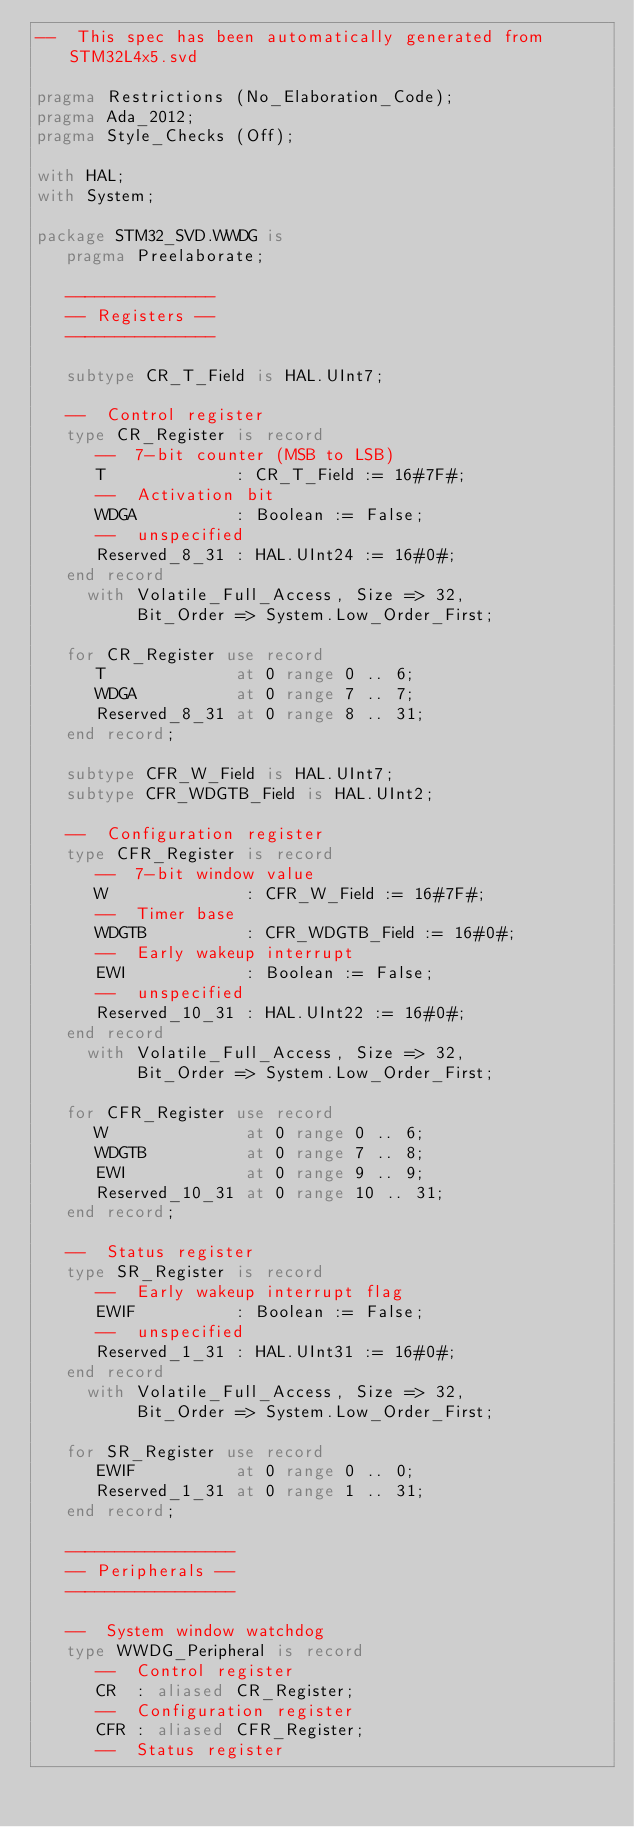<code> <loc_0><loc_0><loc_500><loc_500><_Ada_>--  This spec has been automatically generated from STM32L4x5.svd

pragma Restrictions (No_Elaboration_Code);
pragma Ada_2012;
pragma Style_Checks (Off);

with HAL;
with System;

package STM32_SVD.WWDG is
   pragma Preelaborate;

   ---------------
   -- Registers --
   ---------------

   subtype CR_T_Field is HAL.UInt7;

   --  Control register
   type CR_Register is record
      --  7-bit counter (MSB to LSB)
      T             : CR_T_Field := 16#7F#;
      --  Activation bit
      WDGA          : Boolean := False;
      --  unspecified
      Reserved_8_31 : HAL.UInt24 := 16#0#;
   end record
     with Volatile_Full_Access, Size => 32,
          Bit_Order => System.Low_Order_First;

   for CR_Register use record
      T             at 0 range 0 .. 6;
      WDGA          at 0 range 7 .. 7;
      Reserved_8_31 at 0 range 8 .. 31;
   end record;

   subtype CFR_W_Field is HAL.UInt7;
   subtype CFR_WDGTB_Field is HAL.UInt2;

   --  Configuration register
   type CFR_Register is record
      --  7-bit window value
      W              : CFR_W_Field := 16#7F#;
      --  Timer base
      WDGTB          : CFR_WDGTB_Field := 16#0#;
      --  Early wakeup interrupt
      EWI            : Boolean := False;
      --  unspecified
      Reserved_10_31 : HAL.UInt22 := 16#0#;
   end record
     with Volatile_Full_Access, Size => 32,
          Bit_Order => System.Low_Order_First;

   for CFR_Register use record
      W              at 0 range 0 .. 6;
      WDGTB          at 0 range 7 .. 8;
      EWI            at 0 range 9 .. 9;
      Reserved_10_31 at 0 range 10 .. 31;
   end record;

   --  Status register
   type SR_Register is record
      --  Early wakeup interrupt flag
      EWIF          : Boolean := False;
      --  unspecified
      Reserved_1_31 : HAL.UInt31 := 16#0#;
   end record
     with Volatile_Full_Access, Size => 32,
          Bit_Order => System.Low_Order_First;

   for SR_Register use record
      EWIF          at 0 range 0 .. 0;
      Reserved_1_31 at 0 range 1 .. 31;
   end record;

   -----------------
   -- Peripherals --
   -----------------

   --  System window watchdog
   type WWDG_Peripheral is record
      --  Control register
      CR  : aliased CR_Register;
      --  Configuration register
      CFR : aliased CFR_Register;
      --  Status register</code> 